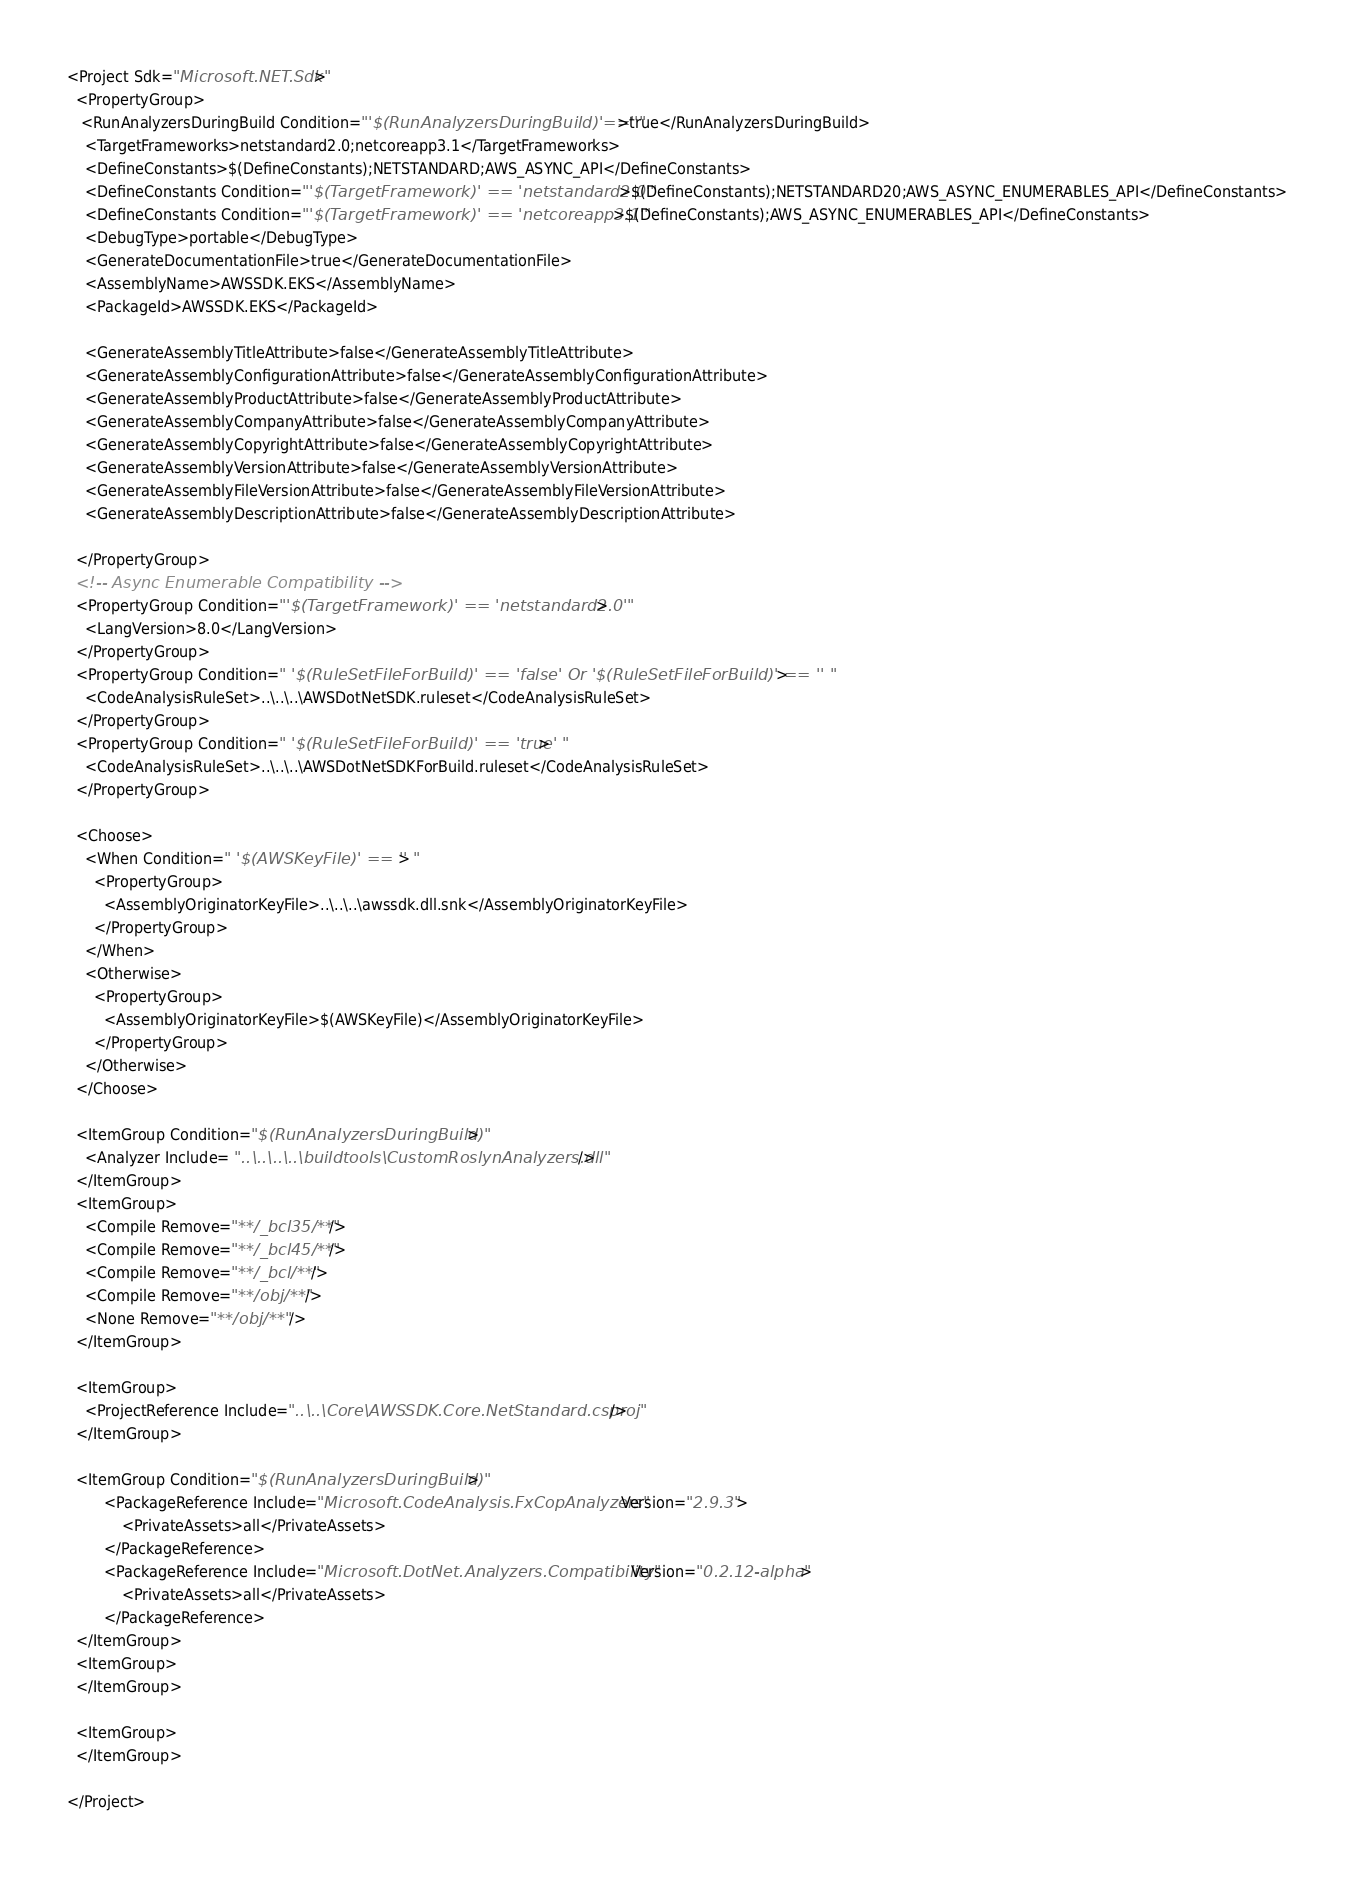<code> <loc_0><loc_0><loc_500><loc_500><_XML_><Project Sdk="Microsoft.NET.Sdk">
  <PropertyGroup>
   <RunAnalyzersDuringBuild Condition="'$(RunAnalyzersDuringBuild)'==''">true</RunAnalyzersDuringBuild>
    <TargetFrameworks>netstandard2.0;netcoreapp3.1</TargetFrameworks>
    <DefineConstants>$(DefineConstants);NETSTANDARD;AWS_ASYNC_API</DefineConstants>
    <DefineConstants Condition="'$(TargetFramework)' == 'netstandard2.0'">$(DefineConstants);NETSTANDARD20;AWS_ASYNC_ENUMERABLES_API</DefineConstants>
    <DefineConstants Condition="'$(TargetFramework)' == 'netcoreapp3.1'">$(DefineConstants);AWS_ASYNC_ENUMERABLES_API</DefineConstants>
    <DebugType>portable</DebugType>
    <GenerateDocumentationFile>true</GenerateDocumentationFile>
    <AssemblyName>AWSSDK.EKS</AssemblyName>
    <PackageId>AWSSDK.EKS</PackageId>

    <GenerateAssemblyTitleAttribute>false</GenerateAssemblyTitleAttribute>
    <GenerateAssemblyConfigurationAttribute>false</GenerateAssemblyConfigurationAttribute>
    <GenerateAssemblyProductAttribute>false</GenerateAssemblyProductAttribute>
    <GenerateAssemblyCompanyAttribute>false</GenerateAssemblyCompanyAttribute>
    <GenerateAssemblyCopyrightAttribute>false</GenerateAssemblyCopyrightAttribute>
    <GenerateAssemblyVersionAttribute>false</GenerateAssemblyVersionAttribute>
    <GenerateAssemblyFileVersionAttribute>false</GenerateAssemblyFileVersionAttribute>
    <GenerateAssemblyDescriptionAttribute>false</GenerateAssemblyDescriptionAttribute>

  </PropertyGroup>
  <!-- Async Enumerable Compatibility -->
  <PropertyGroup Condition="'$(TargetFramework)' == 'netstandard2.0'">
    <LangVersion>8.0</LangVersion>
  </PropertyGroup>
  <PropertyGroup Condition=" '$(RuleSetFileForBuild)' == 'false' Or '$(RuleSetFileForBuild)' == '' ">
    <CodeAnalysisRuleSet>..\..\..\AWSDotNetSDK.ruleset</CodeAnalysisRuleSet>
  </PropertyGroup>
  <PropertyGroup Condition=" '$(RuleSetFileForBuild)' == 'true' ">
    <CodeAnalysisRuleSet>..\..\..\AWSDotNetSDKForBuild.ruleset</CodeAnalysisRuleSet>
  </PropertyGroup>

  <Choose>
    <When Condition=" '$(AWSKeyFile)' == '' ">
      <PropertyGroup>
        <AssemblyOriginatorKeyFile>..\..\..\awssdk.dll.snk</AssemblyOriginatorKeyFile>
      </PropertyGroup>
    </When>
    <Otherwise>
      <PropertyGroup>
        <AssemblyOriginatorKeyFile>$(AWSKeyFile)</AssemblyOriginatorKeyFile>
      </PropertyGroup>
    </Otherwise>
  </Choose>

  <ItemGroup Condition="$(RunAnalyzersDuringBuild)">
    <Analyzer Include= "..\..\..\..\buildtools\CustomRoslynAnalyzers.dll" />
  </ItemGroup>
  <ItemGroup>
    <Compile Remove="**/_bcl35/**"/>
    <Compile Remove="**/_bcl45/**"/>
    <Compile Remove="**/_bcl/**"/>
    <Compile Remove="**/obj/**"/>
    <None Remove="**/obj/**" />
  </ItemGroup>

  <ItemGroup>
    <ProjectReference Include="..\..\Core\AWSSDK.Core.NetStandard.csproj"/>
  </ItemGroup>

  <ItemGroup Condition="$(RunAnalyzersDuringBuild)">
        <PackageReference Include="Microsoft.CodeAnalysis.FxCopAnalyzers" Version="2.9.3">
            <PrivateAssets>all</PrivateAssets>
        </PackageReference>
        <PackageReference Include="Microsoft.DotNet.Analyzers.Compatibility" Version="0.2.12-alpha">
            <PrivateAssets>all</PrivateAssets>
        </PackageReference>
  </ItemGroup>
  <ItemGroup>
  </ItemGroup>

  <ItemGroup>
  </ItemGroup>

</Project></code> 